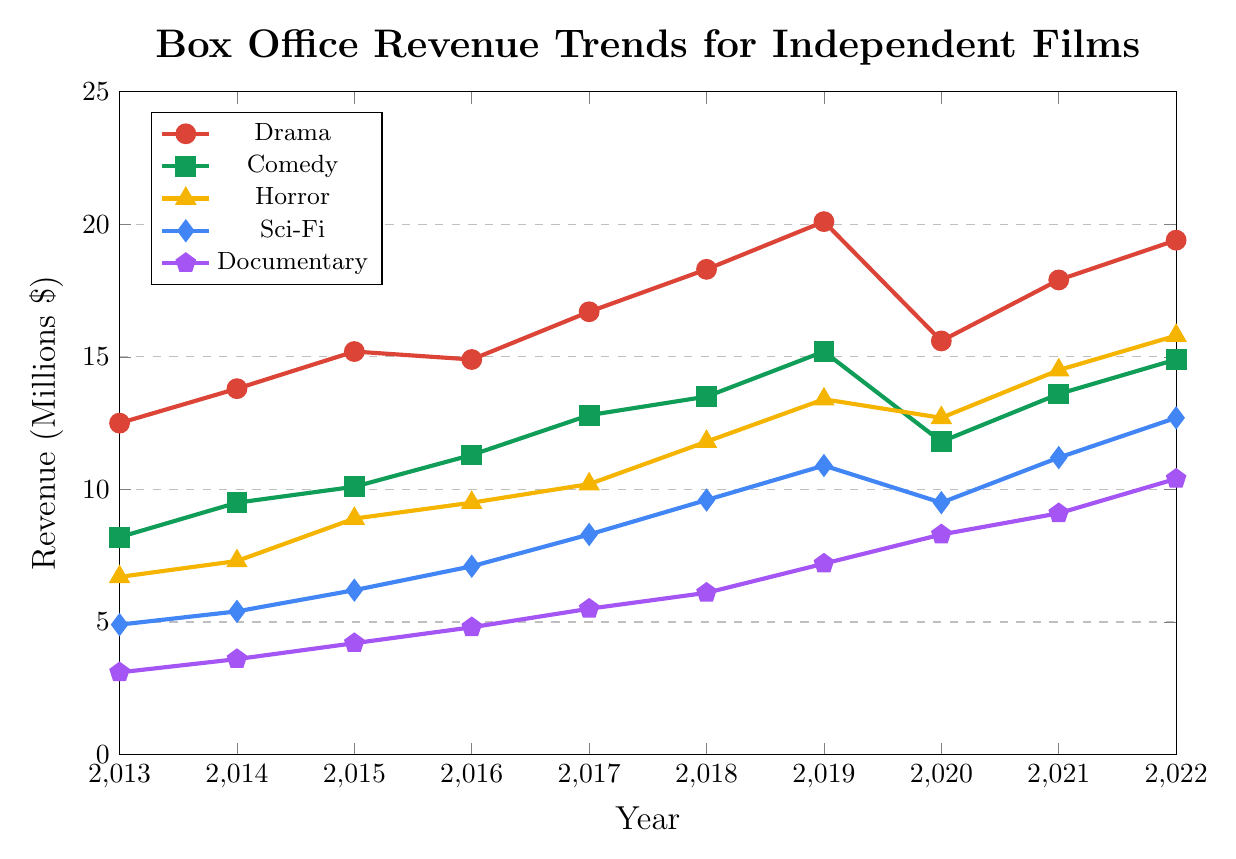What's the genre with the highest box office revenue in 2022? To determine the genre with the highest box office revenue in 2022, look at the endpoint of each line and identify the highest value. The value for Drama is 19.4, for Comedy is 14.9, for Horror is 15.8, for Sci-Fi is 12.7, and for Documentary is 10.4. Drama has the highest value.
Answer: Drama How did the box office revenue for Comedy change from 2019 to 2020? From the chart, the revenue for Comedy in 2019 is 15.2 million, and in 2020 it is 11.8 million. The change is 15.2 - 11.8 = 3.4 million decrease.
Answer: Decreased by 3.4 million What’s the genre with the least box office revenue in 2015? To determine the genre with the least box office revenue in 2015, refer to the points for each genre in 2015. The revenue for Drama is 15.2, Comedy is 10.1, Horror is 8.9, Sci-Fi is 6.2, and Documentary is 4.2. Documentary has the lowest value.
Answer: Documentary Between which years did Horror see the greatest increase in box office revenue? Check the points for Horror each year. The greatest increase is between 2014 (7.3) and 2015 (8.9), which is an increase of 8.9 - 7.3 = 1.6 million.
Answer: 2014 to 2015 Is the box office revenue trend for Sci-Fi generally increasing, decreasing, or stable? Observing the line for Sci-Fi from 2013 to 2022, it shows an overall increasing trend, moving generally upwards despite a slight dip in 2020.
Answer: Increasing What is the average box office revenue for Drama over the decade? Sum all the values for Drama: 12.5 + 13.8 + 15.2 + 14.9 + 16.7 + 18.3 + 20.1 + 15.6 + 17.9 + 19.4 = 164.4. Divide by the number of years (10). 164.4 / 10 = 16.44.
Answer: 16.44 million Compare the box office revenues of Horror and Documentary in 2020. Which one is higher and by how much? From the chart, the revenue for Horror in 2020 is 12.7, and for Documentary, it is 8.3. The difference is 12.7 - 8.3 = 4.4 million, with Horror being higher.
Answer: Horror by 4.4 million What year did Drama see its highest revenue, and what was the revenue value? The highest point on the Drama line is in 2019, with a revenue of 20.1 million.
Answer: 2019, 20.1 million Calculate the overall growth in box office revenue for Documentary from 2013 to 2022. Starting value in 2013 is 3.1 million, and the ending value in 2022 is 10.4 million. The growth is 10.4 - 3.1 = 7.3 million.
Answer: 7.3 million 